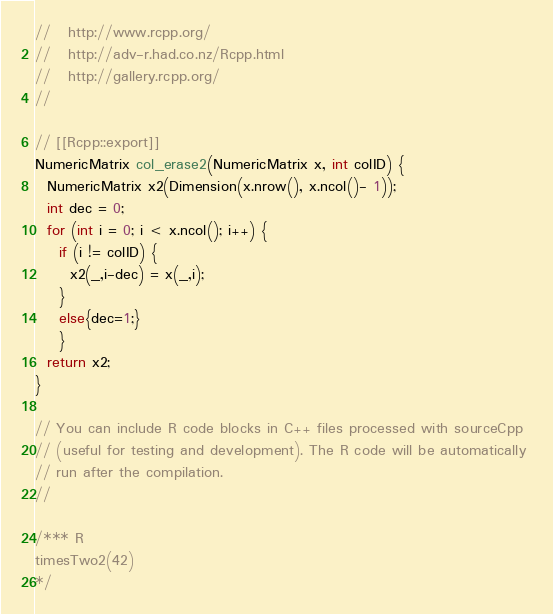Convert code to text. <code><loc_0><loc_0><loc_500><loc_500><_C++_>//   http://www.rcpp.org/
//   http://adv-r.had.co.nz/Rcpp.html
//   http://gallery.rcpp.org/
//

// [[Rcpp::export]]
NumericMatrix col_erase2(NumericMatrix x, int colID) {
  NumericMatrix x2(Dimension(x.nrow(), x.ncol()- 1));
  int dec = 0; 
  for (int i = 0; i < x.ncol(); i++) {
    if (i != colID) {
      x2(_,i-dec) = x(_,i);
    }
    else{dec=1;}
    }
  return x2;
}

// You can include R code blocks in C++ files processed with sourceCpp
// (useful for testing and development). The R code will be automatically 
// run after the compilation.
//

/*** R
timesTwo2(42)
*/
</code> 